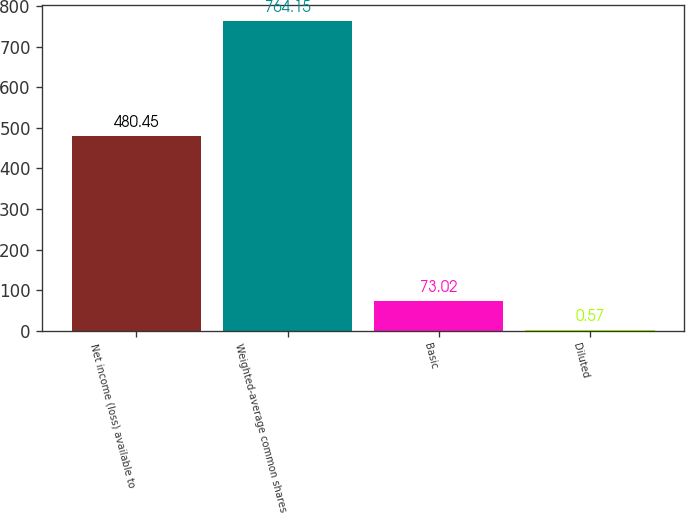Convert chart to OTSL. <chart><loc_0><loc_0><loc_500><loc_500><bar_chart><fcel>Net income (loss) available to<fcel>Weighted-average common shares<fcel>Basic<fcel>Diluted<nl><fcel>480.45<fcel>764.15<fcel>73.02<fcel>0.57<nl></chart> 